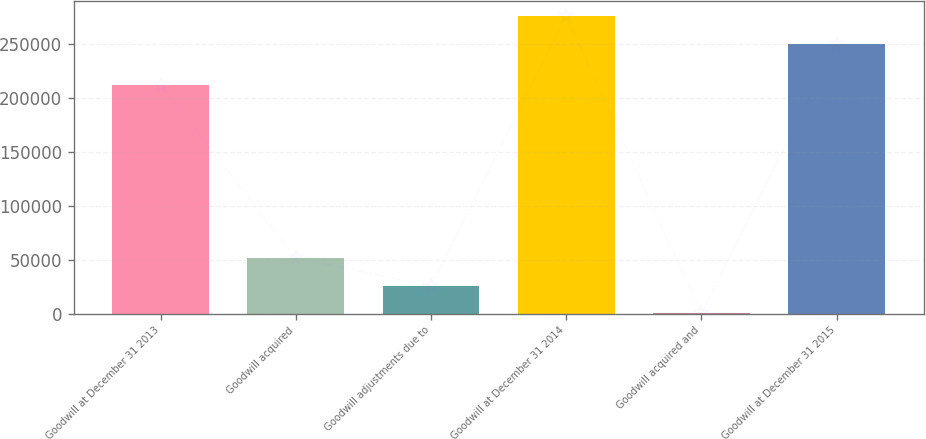<chart> <loc_0><loc_0><loc_500><loc_500><bar_chart><fcel>Goodwill at December 31 2013<fcel>Goodwill acquired<fcel>Goodwill adjustments due to<fcel>Goodwill at December 31 2014<fcel>Goodwill acquired and<fcel>Goodwill at December 31 2015<nl><fcel>211847<fcel>51269.4<fcel>25732.7<fcel>275476<fcel>196<fcel>249939<nl></chart> 